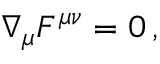Convert formula to latex. <formula><loc_0><loc_0><loc_500><loc_500>\nabla _ { \mu } F ^ { \mu \nu } = 0 \, ,</formula> 